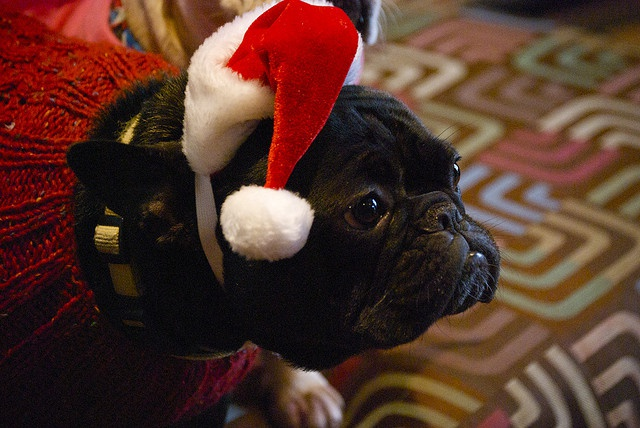Describe the objects in this image and their specific colors. I can see bed in black, maroon, and gray tones and dog in maroon, black, and gray tones in this image. 